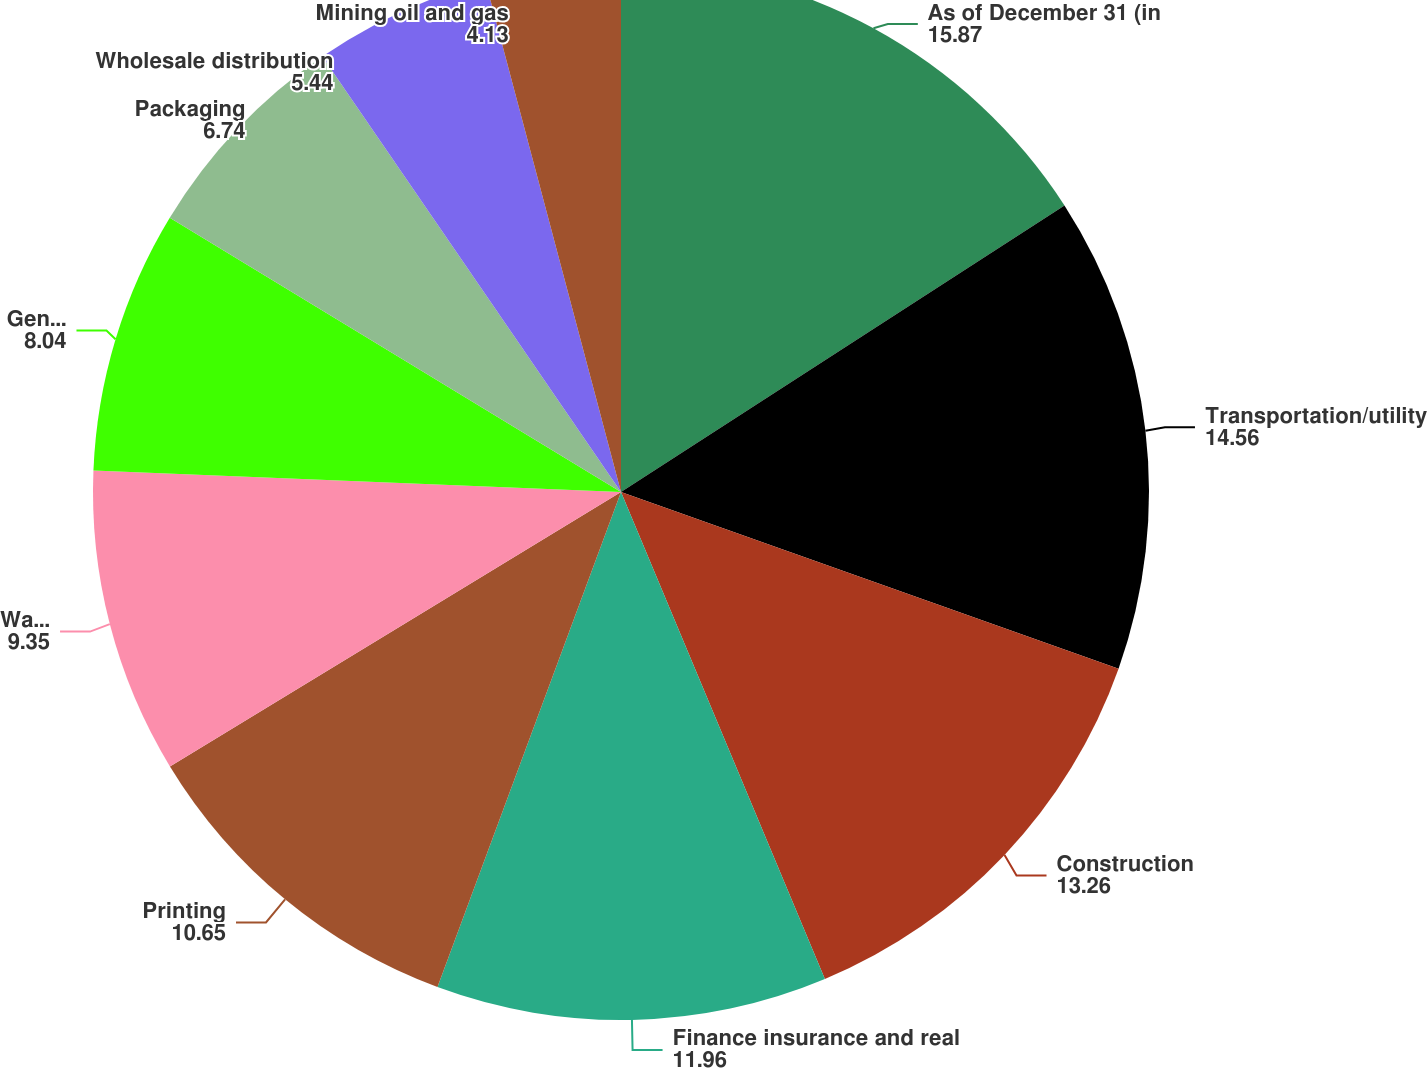Convert chart to OTSL. <chart><loc_0><loc_0><loc_500><loc_500><pie_chart><fcel>As of December 31 (in<fcel>Transportation/utility<fcel>Construction<fcel>Finance insurance and real<fcel>Printing<fcel>Waste<fcel>General manufacturing<fcel>Packaging<fcel>Wholesale distribution<fcel>Mining oil and gas<nl><fcel>15.87%<fcel>14.56%<fcel>13.26%<fcel>11.96%<fcel>10.65%<fcel>9.35%<fcel>8.04%<fcel>6.74%<fcel>5.44%<fcel>4.13%<nl></chart> 